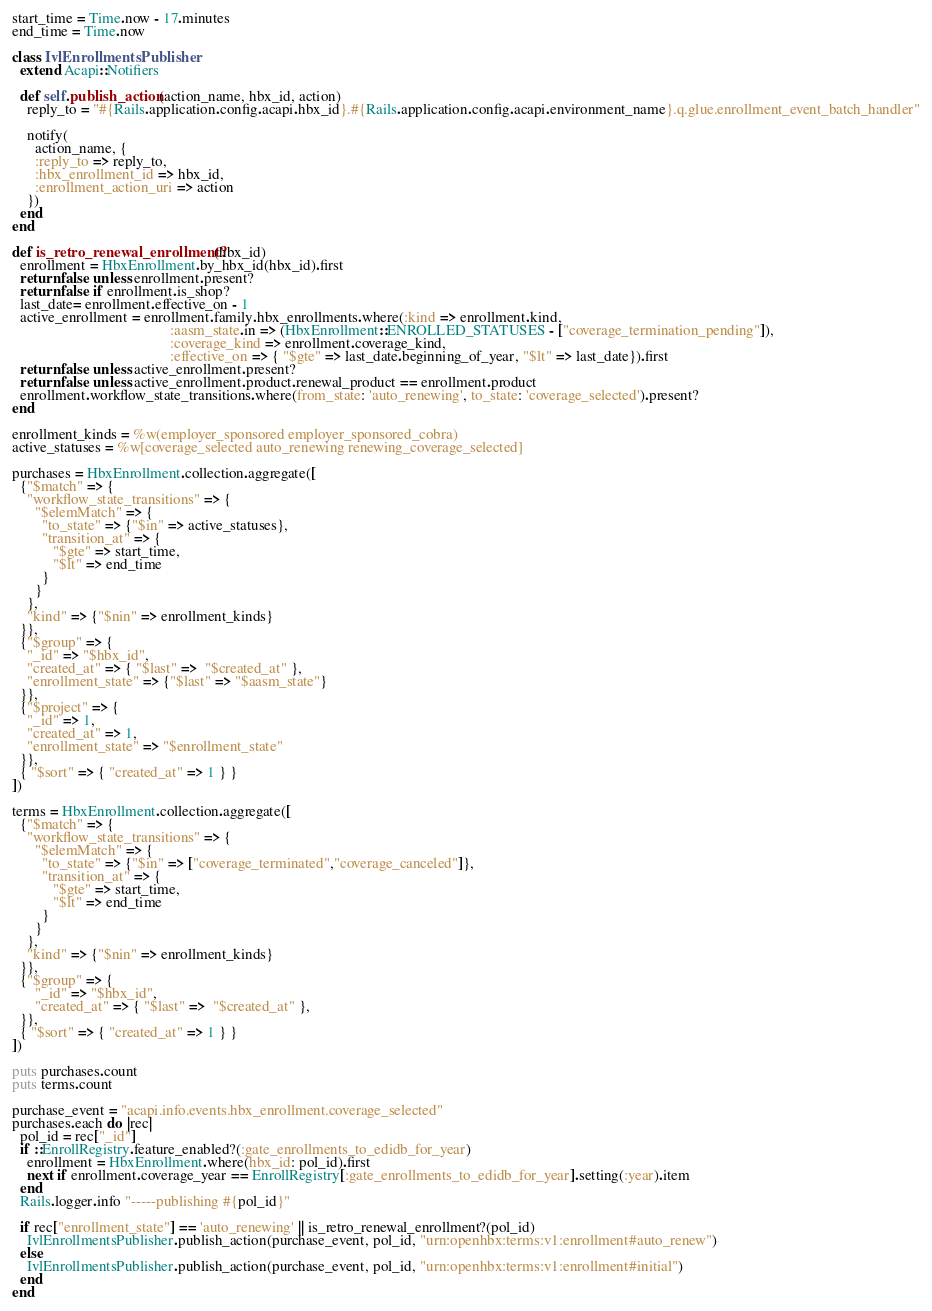Convert code to text. <code><loc_0><loc_0><loc_500><loc_500><_Ruby_>start_time = Time.now - 17.minutes
end_time = Time.now

class IvlEnrollmentsPublisher
  extend Acapi::Notifiers

  def self.publish_action(action_name, hbx_id, action)
    reply_to = "#{Rails.application.config.acapi.hbx_id}.#{Rails.application.config.acapi.environment_name}.q.glue.enrollment_event_batch_handler"

    notify(
      action_name, {
      :reply_to => reply_to,
      :hbx_enrollment_id => hbx_id,
      :enrollment_action_uri => action
    })
  end
end

def is_retro_renewal_enrollment?(hbx_id)
  enrollment = HbxEnrollment.by_hbx_id(hbx_id).first
  return false unless enrollment.present?
  return false if enrollment.is_shop?
  last_date= enrollment.effective_on - 1
  active_enrollment = enrollment.family.hbx_enrollments.where(:kind => enrollment.kind,
                                          :aasm_state.in => (HbxEnrollment::ENROLLED_STATUSES - ["coverage_termination_pending"]),
                                          :coverage_kind => enrollment.coverage_kind,
                                          :effective_on => { "$gte" => last_date.beginning_of_year, "$lt" => last_date}).first
  return false unless active_enrollment.present?
  return false unless active_enrollment.product.renewal_product == enrollment.product
  enrollment.workflow_state_transitions.where(from_state: 'auto_renewing', to_state: 'coverage_selected').present?
end

enrollment_kinds = %w(employer_sponsored employer_sponsored_cobra)
active_statuses = %w[coverage_selected auto_renewing renewing_coverage_selected]

purchases = HbxEnrollment.collection.aggregate([
  {"$match" => {
    "workflow_state_transitions" => {
      "$elemMatch" => {
        "to_state" => {"$in" => active_statuses},
        "transition_at" => {
           "$gte" => start_time,
           "$lt" => end_time
        }
      }
    },
    "kind" => {"$nin" => enrollment_kinds}
  }},
  {"$group" => {
    "_id" => "$hbx_id",
    "created_at" => { "$last" =>  "$created_at" },
    "enrollment_state" => {"$last" => "$aasm_state"}
  }},
  {"$project" => {
    "_id" => 1,
    "created_at" => 1,
    "enrollment_state" => "$enrollment_state"
  }},
  { "$sort" => { "created_at" => 1 } }
])

terms = HbxEnrollment.collection.aggregate([
  {"$match" => {
    "workflow_state_transitions" => {
      "$elemMatch" => {
        "to_state" => {"$in" => ["coverage_terminated","coverage_canceled"]},
        "transition_at" => {
           "$gte" => start_time,
           "$lt" => end_time
        }
      }
    },
    "kind" => {"$nin" => enrollment_kinds}
  }},
  {"$group" => {
      "_id" => "$hbx_id",
      "created_at" => { "$last" =>  "$created_at" },
  }},
  { "$sort" => { "created_at" => 1 } }
])

puts purchases.count
puts terms.count

purchase_event = "acapi.info.events.hbx_enrollment.coverage_selected"
purchases.each do |rec|
  pol_id = rec["_id"]
  if ::EnrollRegistry.feature_enabled?(:gate_enrollments_to_edidb_for_year)
    enrollment = HbxEnrollment.where(hbx_id: pol_id).first
    next if enrollment.coverage_year == EnrollRegistry[:gate_enrollments_to_edidb_for_year].setting(:year).item
  end
  Rails.logger.info "-----publishing #{pol_id}"

  if rec["enrollment_state"] == 'auto_renewing' || is_retro_renewal_enrollment?(pol_id)
    IvlEnrollmentsPublisher.publish_action(purchase_event, pol_id, "urn:openhbx:terms:v1:enrollment#auto_renew")
  else
    IvlEnrollmentsPublisher.publish_action(purchase_event, pol_id, "urn:openhbx:terms:v1:enrollment#initial")
  end
end
</code> 